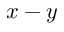<formula> <loc_0><loc_0><loc_500><loc_500>x - y</formula> 